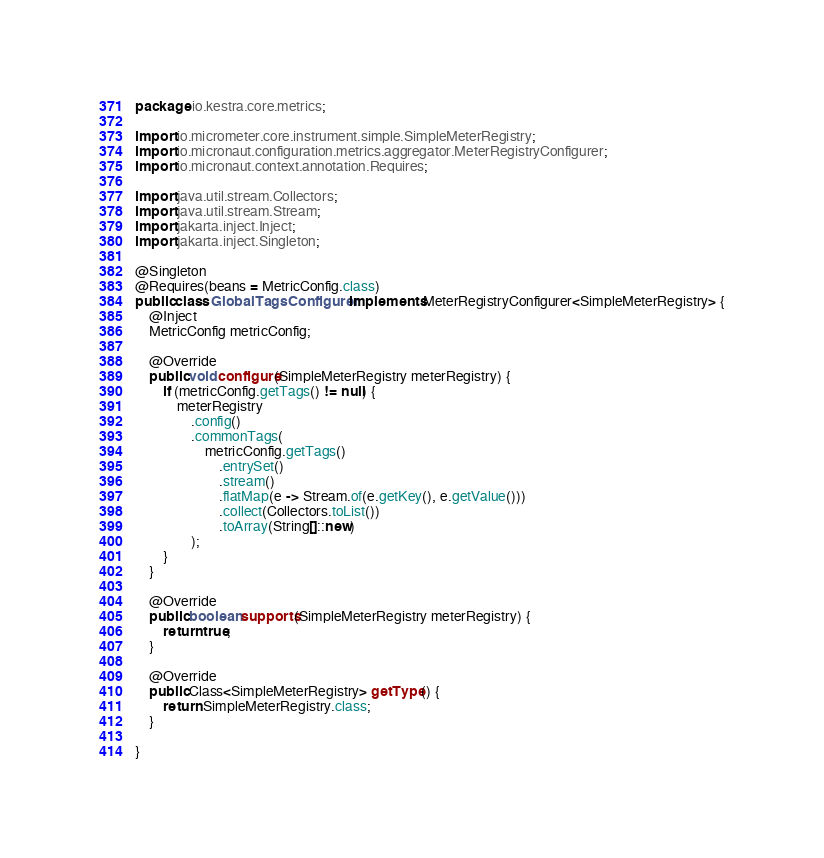Convert code to text. <code><loc_0><loc_0><loc_500><loc_500><_Java_>package io.kestra.core.metrics;

import io.micrometer.core.instrument.simple.SimpleMeterRegistry;
import io.micronaut.configuration.metrics.aggregator.MeterRegistryConfigurer;
import io.micronaut.context.annotation.Requires;

import java.util.stream.Collectors;
import java.util.stream.Stream;
import jakarta.inject.Inject;
import jakarta.inject.Singleton;

@Singleton
@Requires(beans = MetricConfig.class)
public class GlobalTagsConfigurer implements MeterRegistryConfigurer<SimpleMeterRegistry> {
    @Inject
    MetricConfig metricConfig;

    @Override
    public void configure(SimpleMeterRegistry meterRegistry) {
        if (metricConfig.getTags() != null) {
            meterRegistry
                .config()
                .commonTags(
                    metricConfig.getTags()
                        .entrySet()
                        .stream()
                        .flatMap(e -> Stream.of(e.getKey(), e.getValue()))
                        .collect(Collectors.toList())
                        .toArray(String[]::new)
                );
        }
    }

    @Override
    public boolean supports(SimpleMeterRegistry meterRegistry) {
        return true;
    }

    @Override
    public Class<SimpleMeterRegistry> getType() {
        return SimpleMeterRegistry.class;
    }

}</code> 